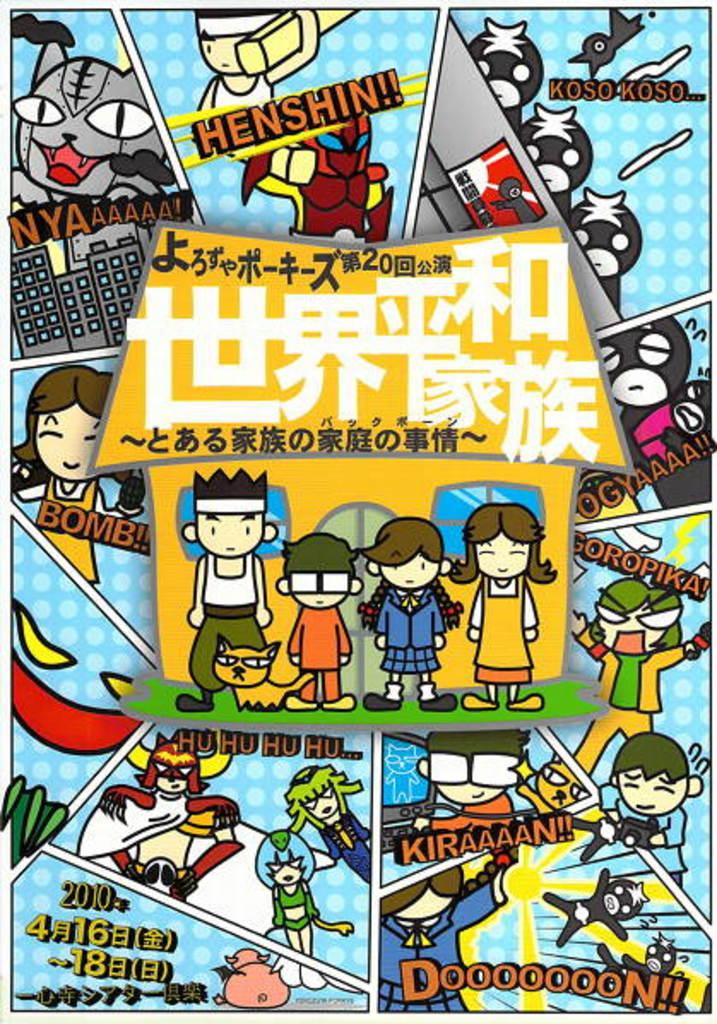What language is this mostly written in?
Provide a short and direct response. Unanswerable. What is written in the top right panel, with the strange looking crows?
Keep it short and to the point. Koso koso. 